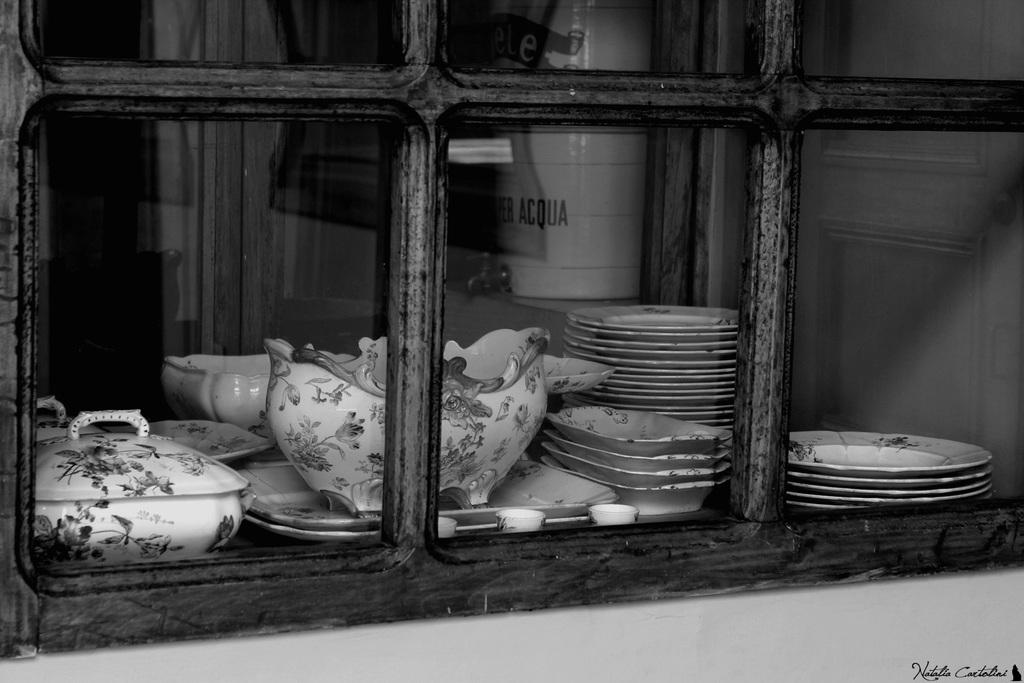What is the color scheme of the image? The image is black and white. What can be seen inside the cupboard in the image? There is crockery placed in a cupboard in the image. How many cats are playing with a substance on the floor in the image? There are no cats or substance present in the image; it only features crockery in a cupboard. 